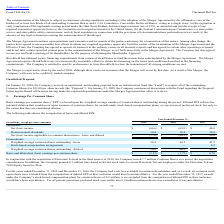According to Cincinnati Bell's financial document, How many shares did the company issue as part of its acquisition consideration of Hawaiian Telcom? According to the financial document, 7.7 (in millions). The relevant text states: "in the third quarter of 2018, the Company issued 7.7 million Common Shares as a part of the acquisition consideration. In addition, the Company granted..." Also, What was the value of the common shares excluded from the computation of diluted EPS for the year ended December 31, 2017? According to the financial document, 0.2 (in millions). The relevant text states: "mmon shareowners - basic and diluted $ (77.0) $ (80.2) $ 29.6..." Also, Which quarter of 2018 did the company grant shares to certain employees of Hawaiian Telcom? According to the financial document, third. The relevant text states: "e affirmative vote of the holders of at least two-thirds of all outstanding Common Shares and 6 3 / 4 % Cumulative Convertible Preferred Shares, voting as..." Also, can you calculate: What is the total Net (loss) income  between 2017 to 2019? Based on the calculation: ($66.6)+($69.8)+$40.0, the result is -96.4 (in millions). This is based on the information: "Net (loss) income $ (66.6) $ (69.8) $ 40.0 Net (loss) income $ (66.6) $ (69.8) $ 40.0 Net (loss) income $ (66.6) $ (69.8) $ 40.0..." The key data points involved are: 40.0, 66.6, 69.8. Also, can you calculate: What is the total basic and diluted net (loss) earnings per common share earned between 2017 to 2019? Based on the calculation: $(1.53)+$(1.73)+$0.70, the result is -2.56. This is based on the information: "ss) earnings per common share $ (1.53) $ (1.73) $ 0.70 d diluted net (loss) earnings per common share $ (1.53) $ (1.73) $ 0.70 net (loss) earnings per common share $ (1.53) $ (1.73) $ 0.70..." The key data points involved are: 0.70, 1.53, 1.73. Additionally, Which year has the largest weighted-average common shares outstanding - basic? According to the financial document, 2019. The relevant text states: "(in millions, except per share amounts) 2019 2018 2017..." 